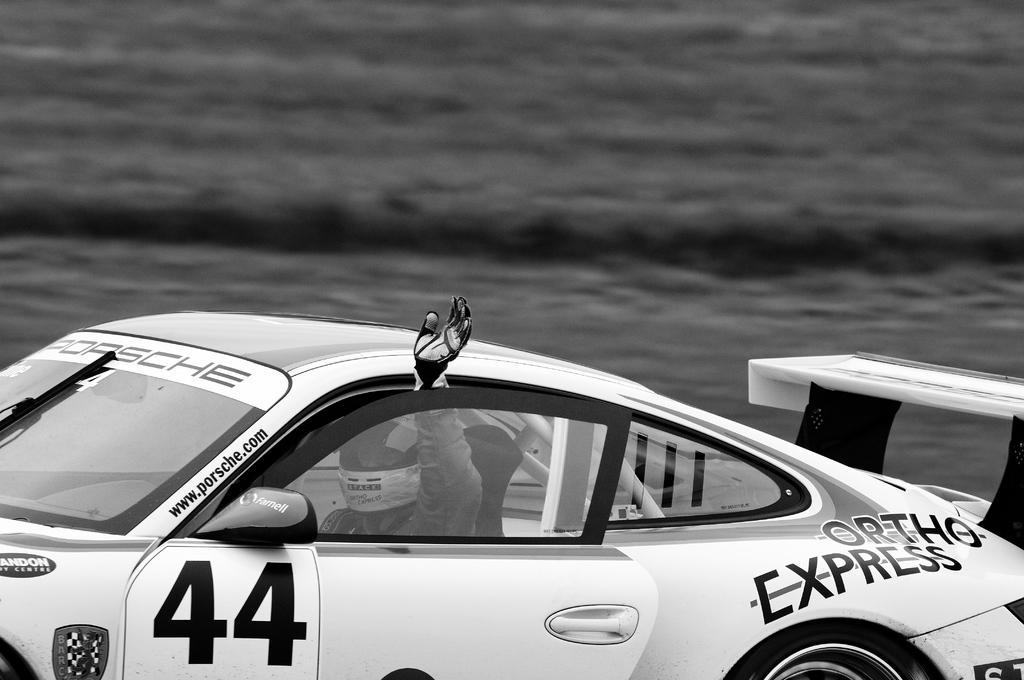Describe this image in one or two sentences. In the foreground of the picture I can see a person in the sports car. He is wearing a helmet and looks like he is waving his hand. I can see the text on the car and the front door of the car is kept open. 